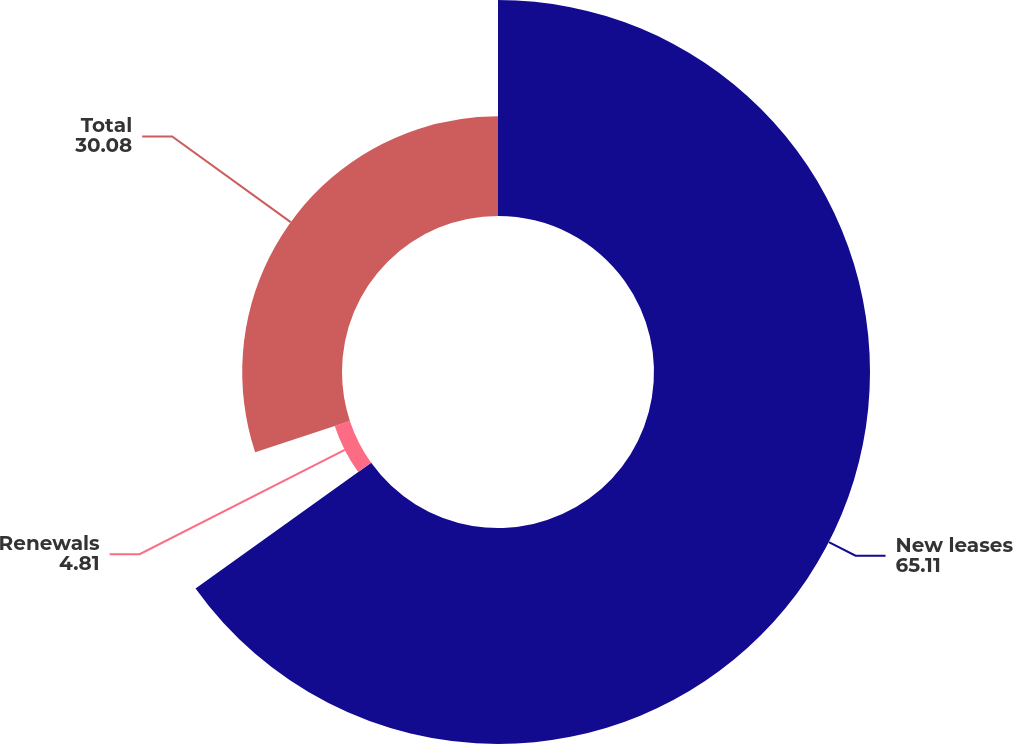<chart> <loc_0><loc_0><loc_500><loc_500><pie_chart><fcel>New leases<fcel>Renewals<fcel>Total<nl><fcel>65.11%<fcel>4.81%<fcel>30.08%<nl></chart> 